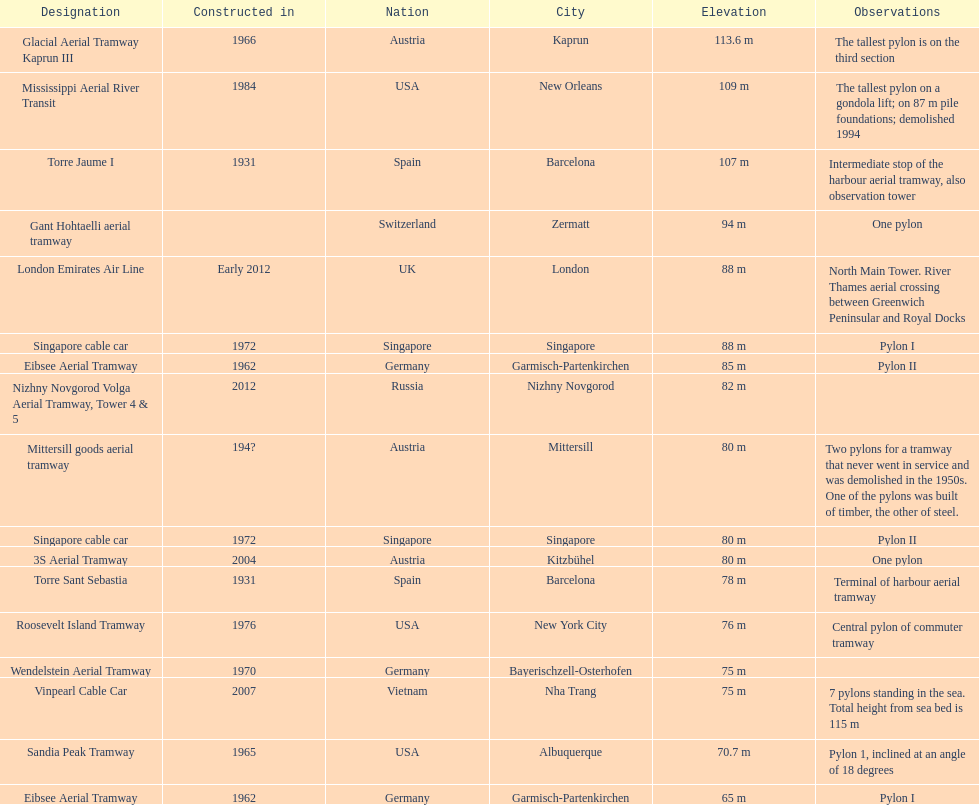Which pylon is the least tall? Eibsee Aerial Tramway. 